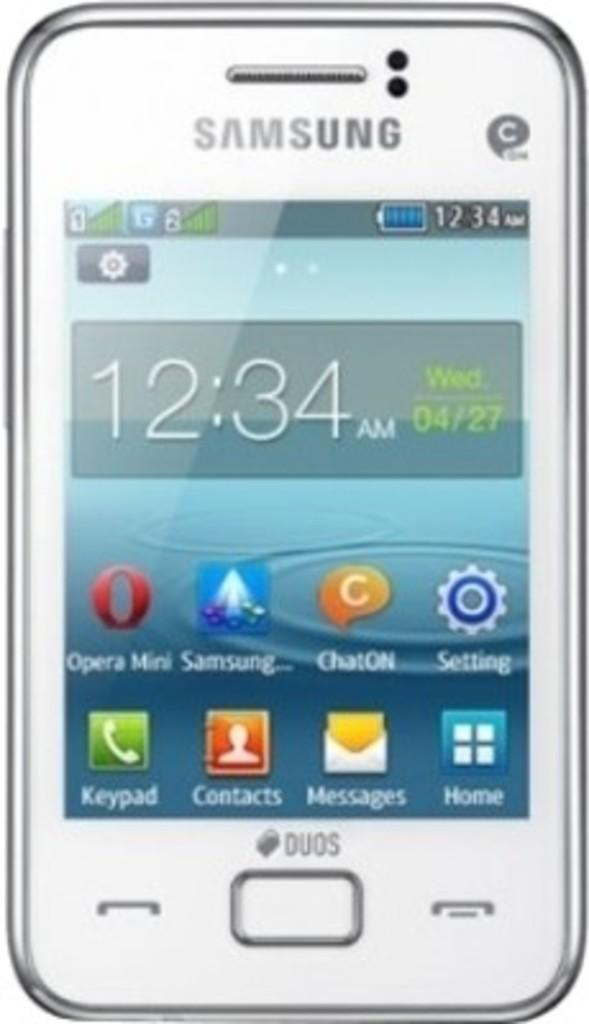<image>
Render a clear and concise summary of the photo. a Samsung phone is opened to the home page 